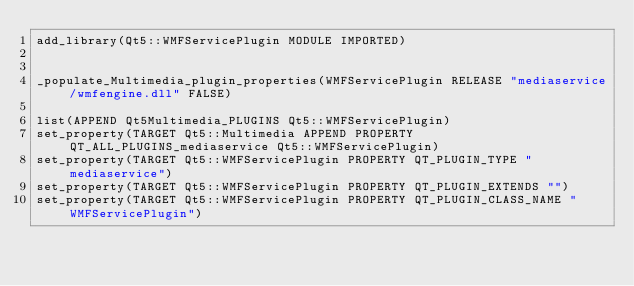Convert code to text. <code><loc_0><loc_0><loc_500><loc_500><_CMake_>add_library(Qt5::WMFServicePlugin MODULE IMPORTED)


_populate_Multimedia_plugin_properties(WMFServicePlugin RELEASE "mediaservice/wmfengine.dll" FALSE)

list(APPEND Qt5Multimedia_PLUGINS Qt5::WMFServicePlugin)
set_property(TARGET Qt5::Multimedia APPEND PROPERTY QT_ALL_PLUGINS_mediaservice Qt5::WMFServicePlugin)
set_property(TARGET Qt5::WMFServicePlugin PROPERTY QT_PLUGIN_TYPE "mediaservice")
set_property(TARGET Qt5::WMFServicePlugin PROPERTY QT_PLUGIN_EXTENDS "")
set_property(TARGET Qt5::WMFServicePlugin PROPERTY QT_PLUGIN_CLASS_NAME "WMFServicePlugin")
</code> 